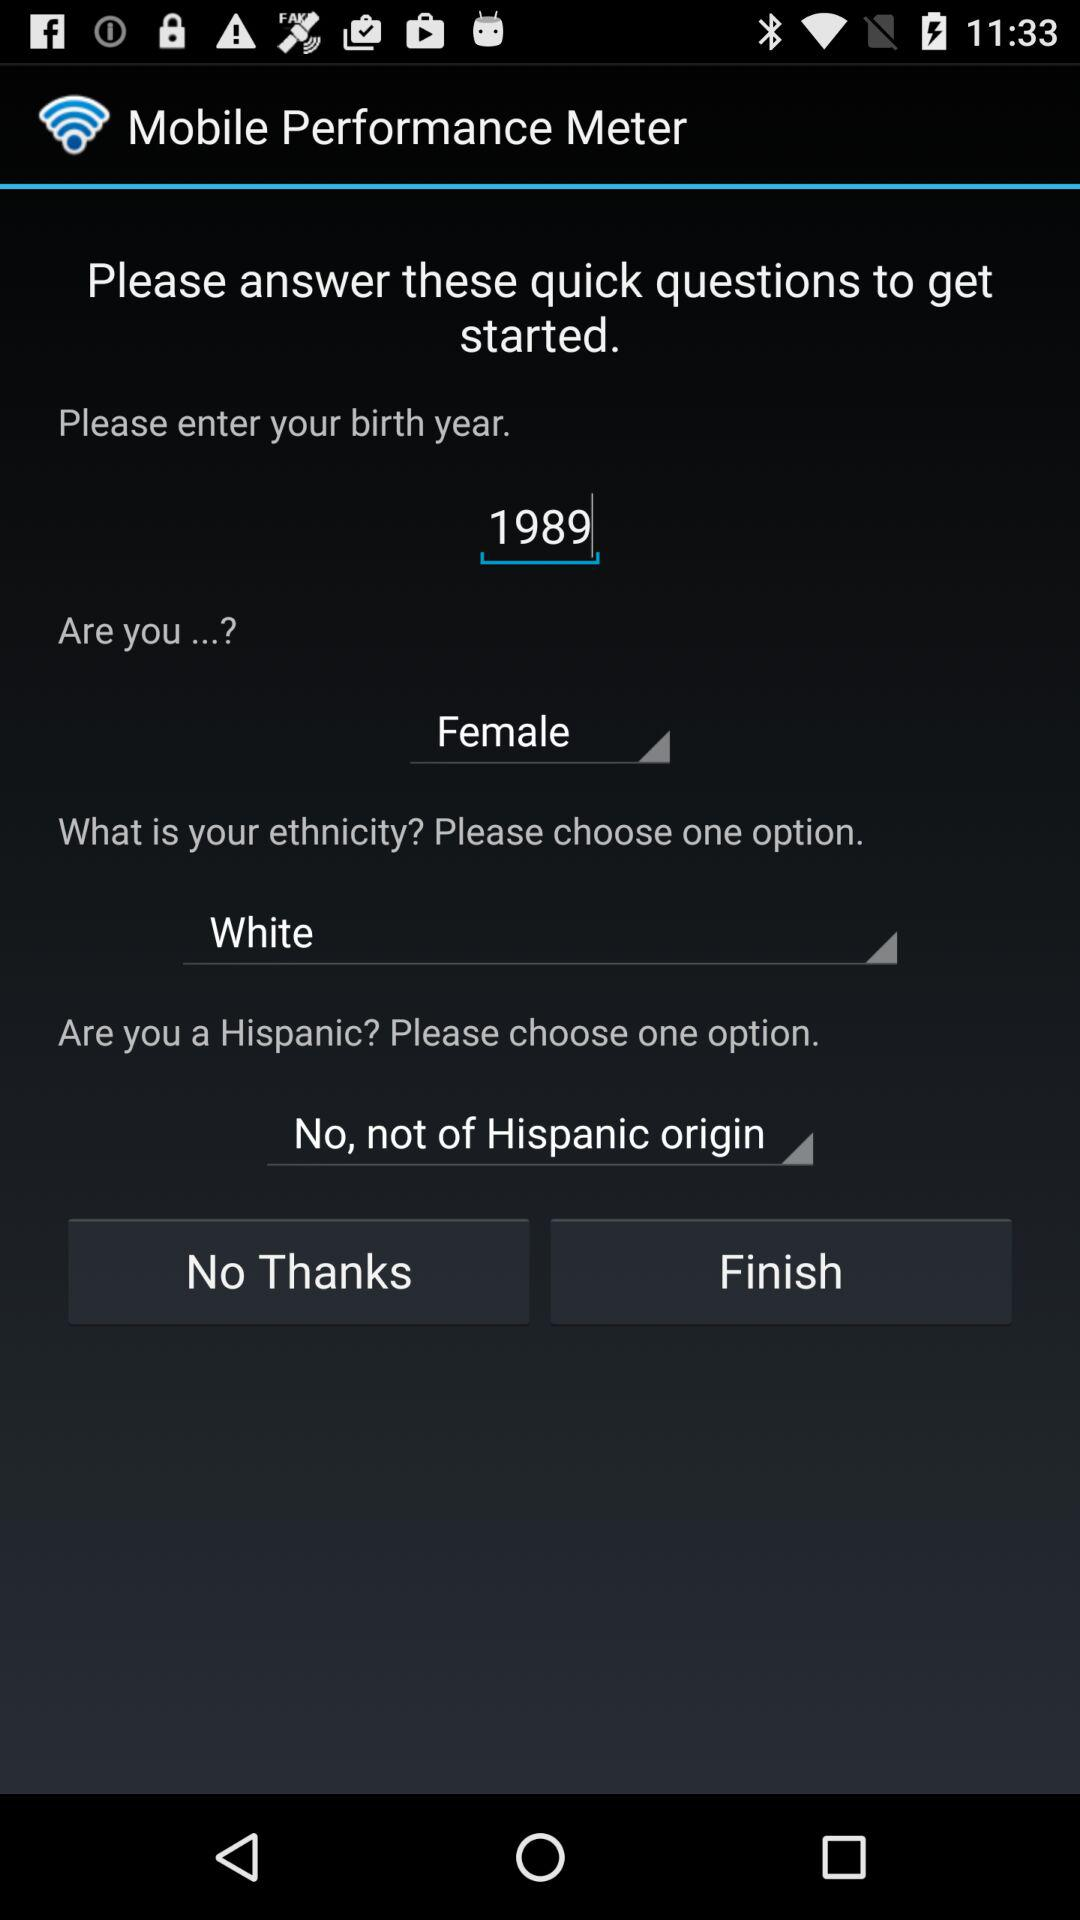What is the given birth year? The given birth year is 1989. 